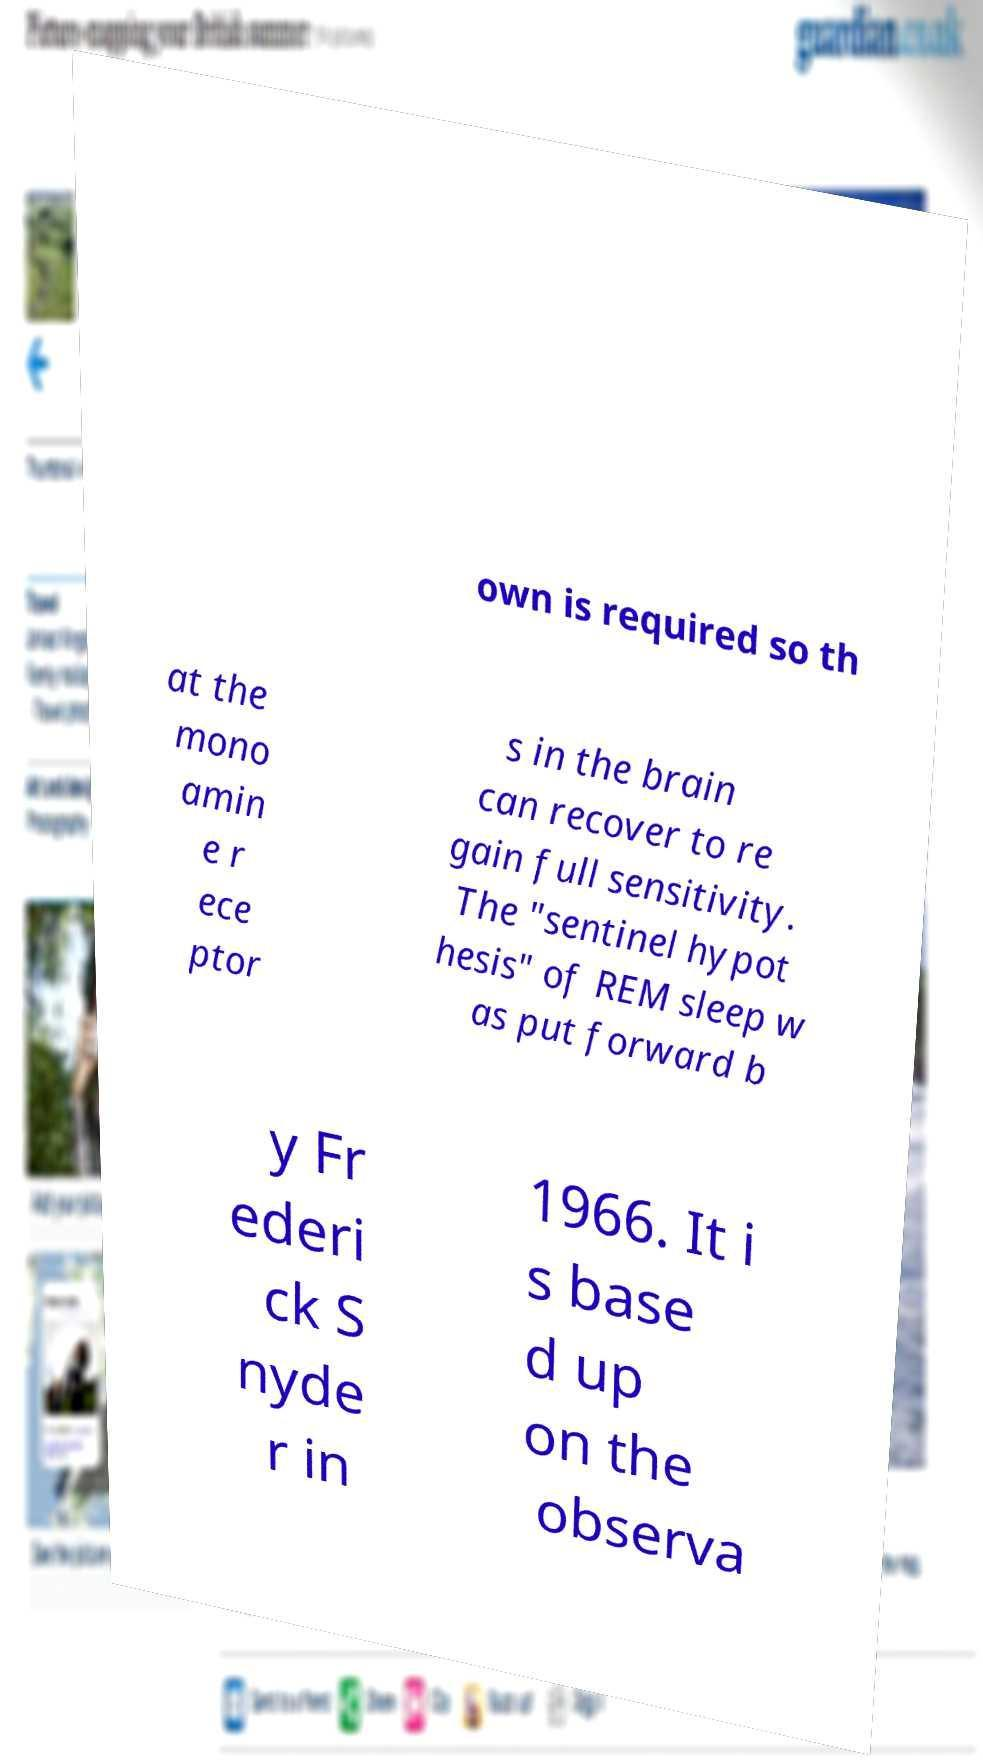For documentation purposes, I need the text within this image transcribed. Could you provide that? own is required so th at the mono amin e r ece ptor s in the brain can recover to re gain full sensitivity. The "sentinel hypot hesis" of REM sleep w as put forward b y Fr ederi ck S nyde r in 1966. It i s base d up on the observa 